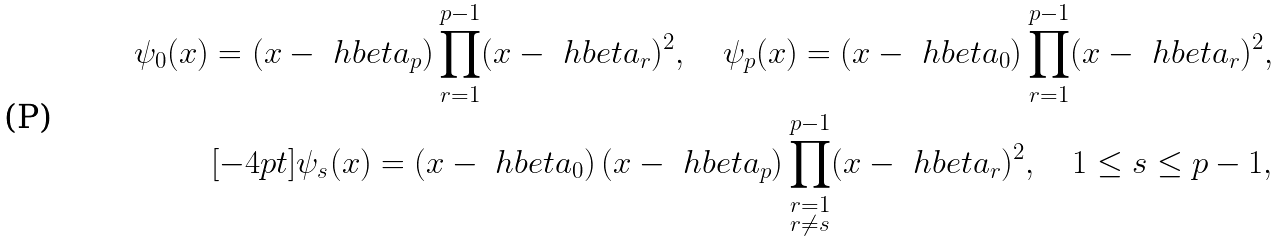Convert formula to latex. <formula><loc_0><loc_0><loc_500><loc_500>\psi _ { 0 } ( x ) = ( x - \ h b e t a _ { p } ) \prod _ { r = 1 } ^ { p - 1 } ( x - \ h b e t a _ { r } ) ^ { 2 } , \quad \psi _ { p } ( x ) = ( x - \ h b e t a _ { 0 } ) \prod _ { r = 1 } ^ { p - 1 } ( x - \ h b e t a _ { r } ) ^ { 2 } , \\ [ - 4 p t ] \psi _ { s } ( x ) = ( x - \ h b e t a _ { 0 } ) \, ( x - \ h b e t a _ { p } ) \prod _ { \substack { r = 1 \\ r \neq s } } ^ { p - 1 } ( x - \ h b e t a _ { r } ) ^ { 2 } , \quad 1 \leq s \leq p - 1 ,</formula> 